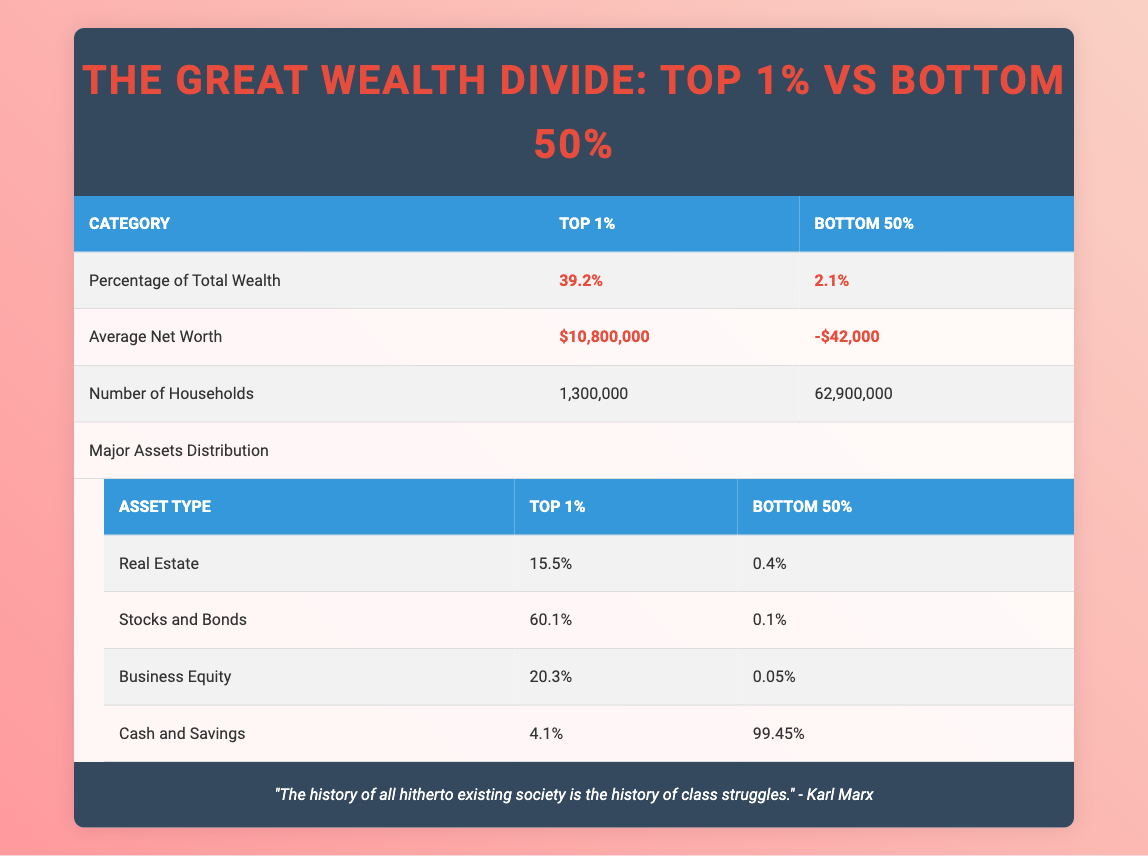What percentage of total wealth is held by the top 1%? From the table, we see that the percentage of total wealth held by the top 1% is explicitly stated as 39.2%.
Answer: 39.2% What is the average net worth of the bottom 50%? The table indicates that the average net worth of the bottom 50% is presented as -$42,000.
Answer: -$42,000 How many more households are in the bottom 50% compared to the top 1%? To find this, we subtract the number of households in the top 1% from those in the bottom 50%. That is 62,900,000 (bottom 50%) - 1,300,000 (top 1%) = 61,600,000.
Answer: 61,600,000 Do the top 1% hold more real estate assets than the bottom 50%? The table shows that the top 1% hold 15.5% in real estate, while the bottom 50% hold only 0.4%. Thus, the top 1% indeed hold more.
Answer: Yes What is the total percentage of major assets held by the top 1% across all types? We need to add the percentages of all major assets for the top 1%: 15.5% (Real Estate) + 60.1% (Stocks and Bonds) + 20.3% (Business Equity) + 4.1% (Cash and Savings) = 100%.
Answer: 100% Is the average net worth of the top 1% greater than zero? The average net worth of the top 1% is stated as $10,800,000, which is indeed greater than zero.
Answer: Yes How much percentage of the total wealth is held by the bottom 50%, compared to the wealth held by the top 1%? The bottom 50% hold 2.1% of total wealth, while the top 1% hold 39.2%. This indicates that the bottom 50% hold significantly less compared to the top 1%.
Answer: 2.1% vs 39.2% What fraction of the total wealth do the bottom 50% and top 1% hold together? To find the combined percentage, we add the percentage of total wealth held by both groups: 39.2% (top 1%) + 2.1% (bottom 50%) = 41.3%.
Answer: 41.3% What percentage of cash and savings do the bottom 50% have compared to the top 1%? The bottom 50% have 99.45% in cash and savings, while the top 1% have 4.1%. The bottom 50% hold a far greater percentage of cash and savings.
Answer: 99.45% vs 4.1% 